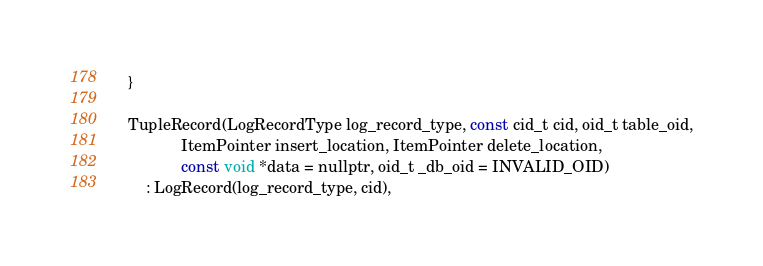Convert code to text. <code><loc_0><loc_0><loc_500><loc_500><_C_>  }

  TupleRecord(LogRecordType log_record_type, const cid_t cid, oid_t table_oid,
              ItemPointer insert_location, ItemPointer delete_location,
              const void *data = nullptr, oid_t _db_oid = INVALID_OID)
      : LogRecord(log_record_type, cid),</code> 